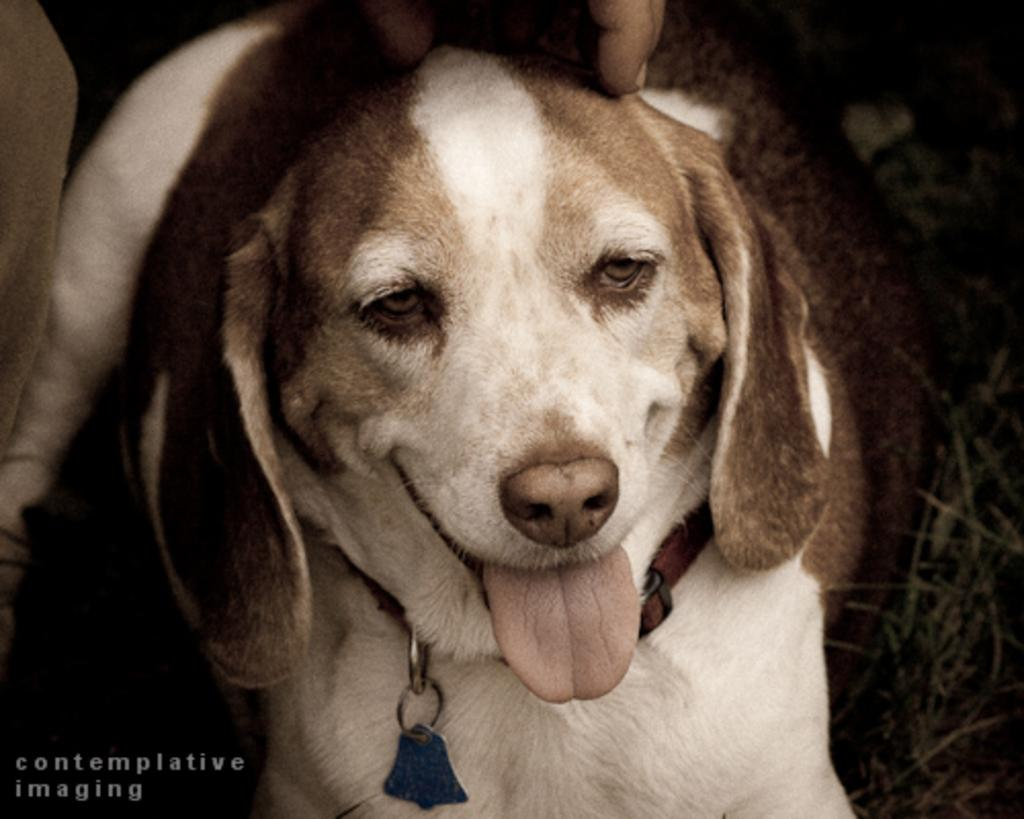What type of animal is present in the image? There is a white color dog in the image. Can you describe any human interaction with the dog? A human hand is visible in the image. What is the dog wearing around its neck? There is a belt over the dog's neck in the image. What type of jelly is being spread on the side of the dog in the image? There is no jelly present in the image, nor is any being spread on the dog. 